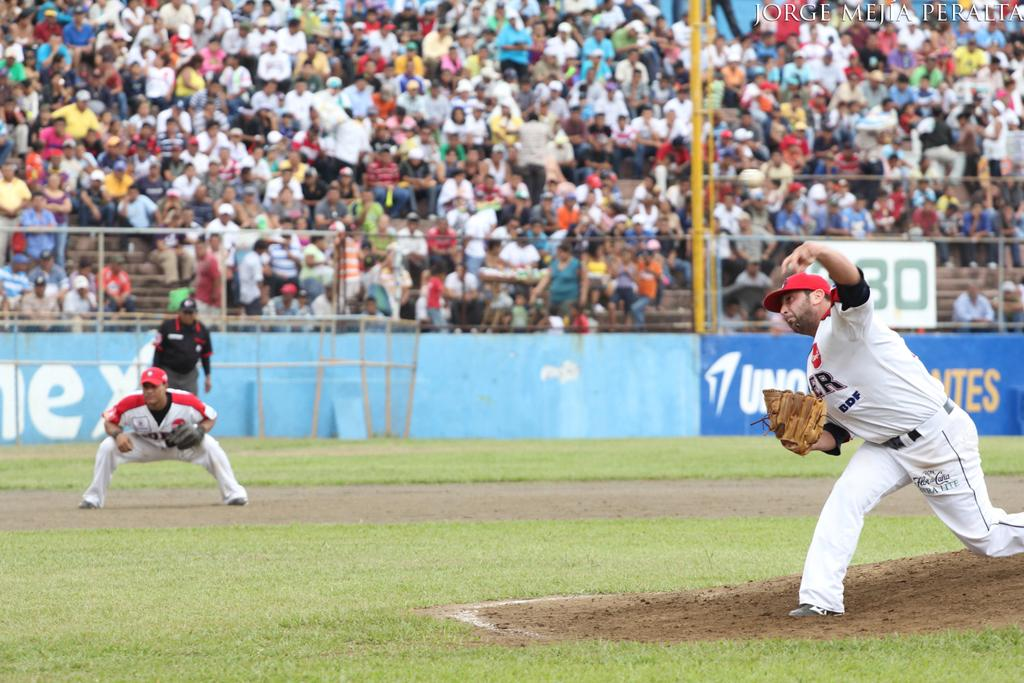<image>
Summarize the visual content of the image. Baeball player with number 3 on his shirt throwing the ball. 